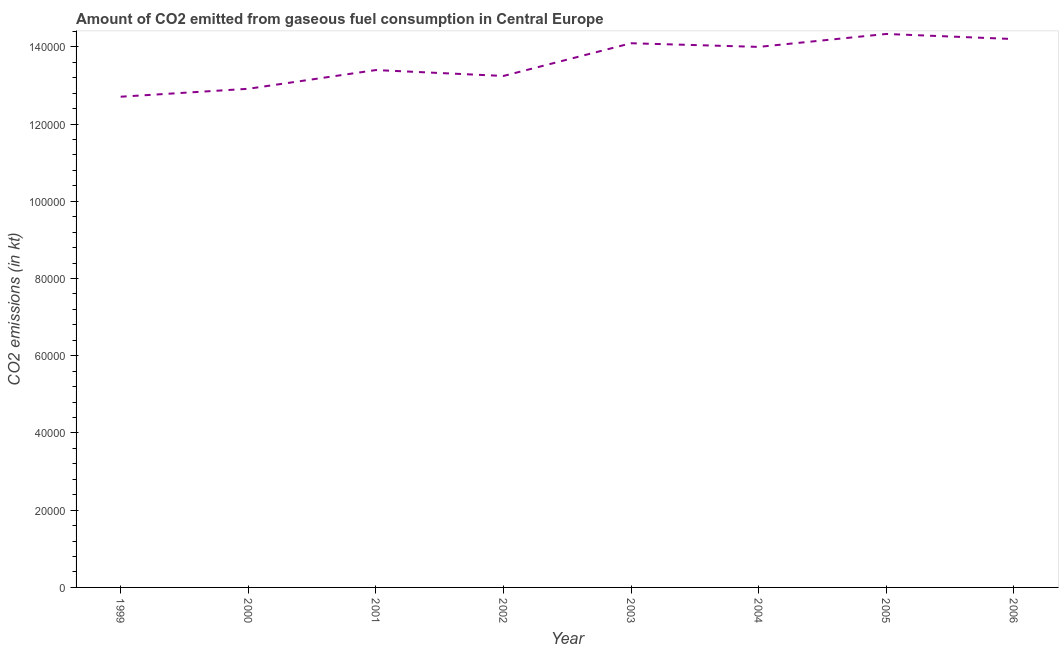What is the co2 emissions from gaseous fuel consumption in 2004?
Provide a short and direct response. 1.40e+05. Across all years, what is the maximum co2 emissions from gaseous fuel consumption?
Your response must be concise. 1.43e+05. Across all years, what is the minimum co2 emissions from gaseous fuel consumption?
Offer a terse response. 1.27e+05. In which year was the co2 emissions from gaseous fuel consumption minimum?
Your answer should be compact. 1999. What is the sum of the co2 emissions from gaseous fuel consumption?
Keep it short and to the point. 1.09e+06. What is the difference between the co2 emissions from gaseous fuel consumption in 1999 and 2005?
Ensure brevity in your answer.  -1.63e+04. What is the average co2 emissions from gaseous fuel consumption per year?
Keep it short and to the point. 1.36e+05. What is the median co2 emissions from gaseous fuel consumption?
Provide a short and direct response. 1.37e+05. In how many years, is the co2 emissions from gaseous fuel consumption greater than 124000 kt?
Make the answer very short. 8. Do a majority of the years between 2006 and 2000 (inclusive) have co2 emissions from gaseous fuel consumption greater than 76000 kt?
Your response must be concise. Yes. What is the ratio of the co2 emissions from gaseous fuel consumption in 2000 to that in 2002?
Your answer should be compact. 0.97. Is the co2 emissions from gaseous fuel consumption in 2001 less than that in 2003?
Provide a short and direct response. Yes. Is the difference between the co2 emissions from gaseous fuel consumption in 2000 and 2006 greater than the difference between any two years?
Your answer should be compact. No. What is the difference between the highest and the second highest co2 emissions from gaseous fuel consumption?
Provide a succinct answer. 1320.12. Is the sum of the co2 emissions from gaseous fuel consumption in 2004 and 2006 greater than the maximum co2 emissions from gaseous fuel consumption across all years?
Your answer should be very brief. Yes. What is the difference between the highest and the lowest co2 emissions from gaseous fuel consumption?
Offer a very short reply. 1.63e+04. In how many years, is the co2 emissions from gaseous fuel consumption greater than the average co2 emissions from gaseous fuel consumption taken over all years?
Offer a very short reply. 4. How many lines are there?
Provide a succinct answer. 1. How many years are there in the graph?
Offer a very short reply. 8. Are the values on the major ticks of Y-axis written in scientific E-notation?
Provide a short and direct response. No. What is the title of the graph?
Make the answer very short. Amount of CO2 emitted from gaseous fuel consumption in Central Europe. What is the label or title of the Y-axis?
Offer a very short reply. CO2 emissions (in kt). What is the CO2 emissions (in kt) of 1999?
Ensure brevity in your answer.  1.27e+05. What is the CO2 emissions (in kt) in 2000?
Your response must be concise. 1.29e+05. What is the CO2 emissions (in kt) of 2001?
Your answer should be compact. 1.34e+05. What is the CO2 emissions (in kt) in 2002?
Make the answer very short. 1.32e+05. What is the CO2 emissions (in kt) in 2003?
Your answer should be compact. 1.41e+05. What is the CO2 emissions (in kt) of 2004?
Make the answer very short. 1.40e+05. What is the CO2 emissions (in kt) in 2005?
Give a very brief answer. 1.43e+05. What is the CO2 emissions (in kt) of 2006?
Ensure brevity in your answer.  1.42e+05. What is the difference between the CO2 emissions (in kt) in 1999 and 2000?
Offer a very short reply. -2057.19. What is the difference between the CO2 emissions (in kt) in 1999 and 2001?
Provide a succinct answer. -6904.96. What is the difference between the CO2 emissions (in kt) in 1999 and 2002?
Your answer should be compact. -5375.82. What is the difference between the CO2 emissions (in kt) in 1999 and 2003?
Give a very brief answer. -1.39e+04. What is the difference between the CO2 emissions (in kt) in 1999 and 2004?
Your answer should be compact. -1.29e+04. What is the difference between the CO2 emissions (in kt) in 1999 and 2005?
Give a very brief answer. -1.63e+04. What is the difference between the CO2 emissions (in kt) in 1999 and 2006?
Give a very brief answer. -1.49e+04. What is the difference between the CO2 emissions (in kt) in 2000 and 2001?
Your response must be concise. -4847.77. What is the difference between the CO2 emissions (in kt) in 2000 and 2002?
Your response must be concise. -3318.64. What is the difference between the CO2 emissions (in kt) in 2000 and 2003?
Your response must be concise. -1.18e+04. What is the difference between the CO2 emissions (in kt) in 2000 and 2004?
Provide a short and direct response. -1.08e+04. What is the difference between the CO2 emissions (in kt) in 2000 and 2005?
Provide a short and direct response. -1.42e+04. What is the difference between the CO2 emissions (in kt) in 2000 and 2006?
Provide a succinct answer. -1.29e+04. What is the difference between the CO2 emissions (in kt) in 2001 and 2002?
Give a very brief answer. 1529.14. What is the difference between the CO2 emissions (in kt) in 2001 and 2003?
Ensure brevity in your answer.  -6945.3. What is the difference between the CO2 emissions (in kt) in 2001 and 2004?
Make the answer very short. -5995.55. What is the difference between the CO2 emissions (in kt) in 2001 and 2005?
Give a very brief answer. -9347.18. What is the difference between the CO2 emissions (in kt) in 2001 and 2006?
Provide a succinct answer. -8027.06. What is the difference between the CO2 emissions (in kt) in 2002 and 2003?
Make the answer very short. -8474.44. What is the difference between the CO2 emissions (in kt) in 2002 and 2004?
Your answer should be compact. -7524.68. What is the difference between the CO2 emissions (in kt) in 2002 and 2005?
Ensure brevity in your answer.  -1.09e+04. What is the difference between the CO2 emissions (in kt) in 2002 and 2006?
Your response must be concise. -9556.2. What is the difference between the CO2 emissions (in kt) in 2003 and 2004?
Your answer should be compact. 949.75. What is the difference between the CO2 emissions (in kt) in 2003 and 2005?
Provide a short and direct response. -2401.89. What is the difference between the CO2 emissions (in kt) in 2003 and 2006?
Offer a terse response. -1081.77. What is the difference between the CO2 emissions (in kt) in 2004 and 2005?
Your response must be concise. -3351.64. What is the difference between the CO2 emissions (in kt) in 2004 and 2006?
Offer a terse response. -2031.52. What is the difference between the CO2 emissions (in kt) in 2005 and 2006?
Give a very brief answer. 1320.12. What is the ratio of the CO2 emissions (in kt) in 1999 to that in 2000?
Your answer should be compact. 0.98. What is the ratio of the CO2 emissions (in kt) in 1999 to that in 2001?
Your answer should be very brief. 0.95. What is the ratio of the CO2 emissions (in kt) in 1999 to that in 2003?
Ensure brevity in your answer.  0.9. What is the ratio of the CO2 emissions (in kt) in 1999 to that in 2004?
Keep it short and to the point. 0.91. What is the ratio of the CO2 emissions (in kt) in 1999 to that in 2005?
Make the answer very short. 0.89. What is the ratio of the CO2 emissions (in kt) in 1999 to that in 2006?
Provide a short and direct response. 0.9. What is the ratio of the CO2 emissions (in kt) in 2000 to that in 2001?
Your answer should be very brief. 0.96. What is the ratio of the CO2 emissions (in kt) in 2000 to that in 2002?
Offer a very short reply. 0.97. What is the ratio of the CO2 emissions (in kt) in 2000 to that in 2003?
Your answer should be compact. 0.92. What is the ratio of the CO2 emissions (in kt) in 2000 to that in 2004?
Your response must be concise. 0.92. What is the ratio of the CO2 emissions (in kt) in 2000 to that in 2005?
Your response must be concise. 0.9. What is the ratio of the CO2 emissions (in kt) in 2000 to that in 2006?
Offer a terse response. 0.91. What is the ratio of the CO2 emissions (in kt) in 2001 to that in 2002?
Keep it short and to the point. 1.01. What is the ratio of the CO2 emissions (in kt) in 2001 to that in 2003?
Ensure brevity in your answer.  0.95. What is the ratio of the CO2 emissions (in kt) in 2001 to that in 2005?
Provide a succinct answer. 0.94. What is the ratio of the CO2 emissions (in kt) in 2001 to that in 2006?
Provide a short and direct response. 0.94. What is the ratio of the CO2 emissions (in kt) in 2002 to that in 2004?
Keep it short and to the point. 0.95. What is the ratio of the CO2 emissions (in kt) in 2002 to that in 2005?
Provide a short and direct response. 0.92. What is the ratio of the CO2 emissions (in kt) in 2002 to that in 2006?
Offer a terse response. 0.93. What is the ratio of the CO2 emissions (in kt) in 2003 to that in 2005?
Your answer should be compact. 0.98. What is the ratio of the CO2 emissions (in kt) in 2003 to that in 2006?
Your response must be concise. 0.99. What is the ratio of the CO2 emissions (in kt) in 2004 to that in 2005?
Offer a very short reply. 0.98. What is the ratio of the CO2 emissions (in kt) in 2004 to that in 2006?
Your response must be concise. 0.99. 